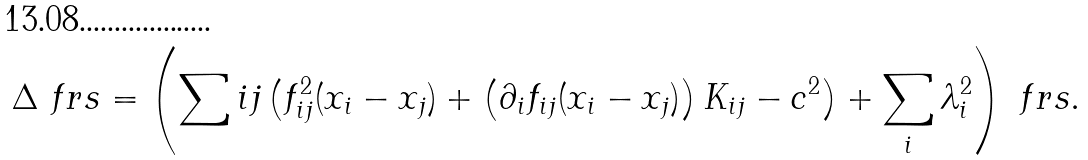<formula> <loc_0><loc_0><loc_500><loc_500>\Delta \ f { r s } = \left ( \sum i j \left ( f _ { i j } ^ { 2 } ( x _ { i } - x _ { j } ) + \left ( \partial _ { i } f _ { i j } ( x _ { i } - x _ { j } ) \right ) K _ { i j } - c ^ { 2 } \right ) + \sum _ { i } \lambda _ { i } ^ { 2 } \right ) \ f { r s } .</formula> 